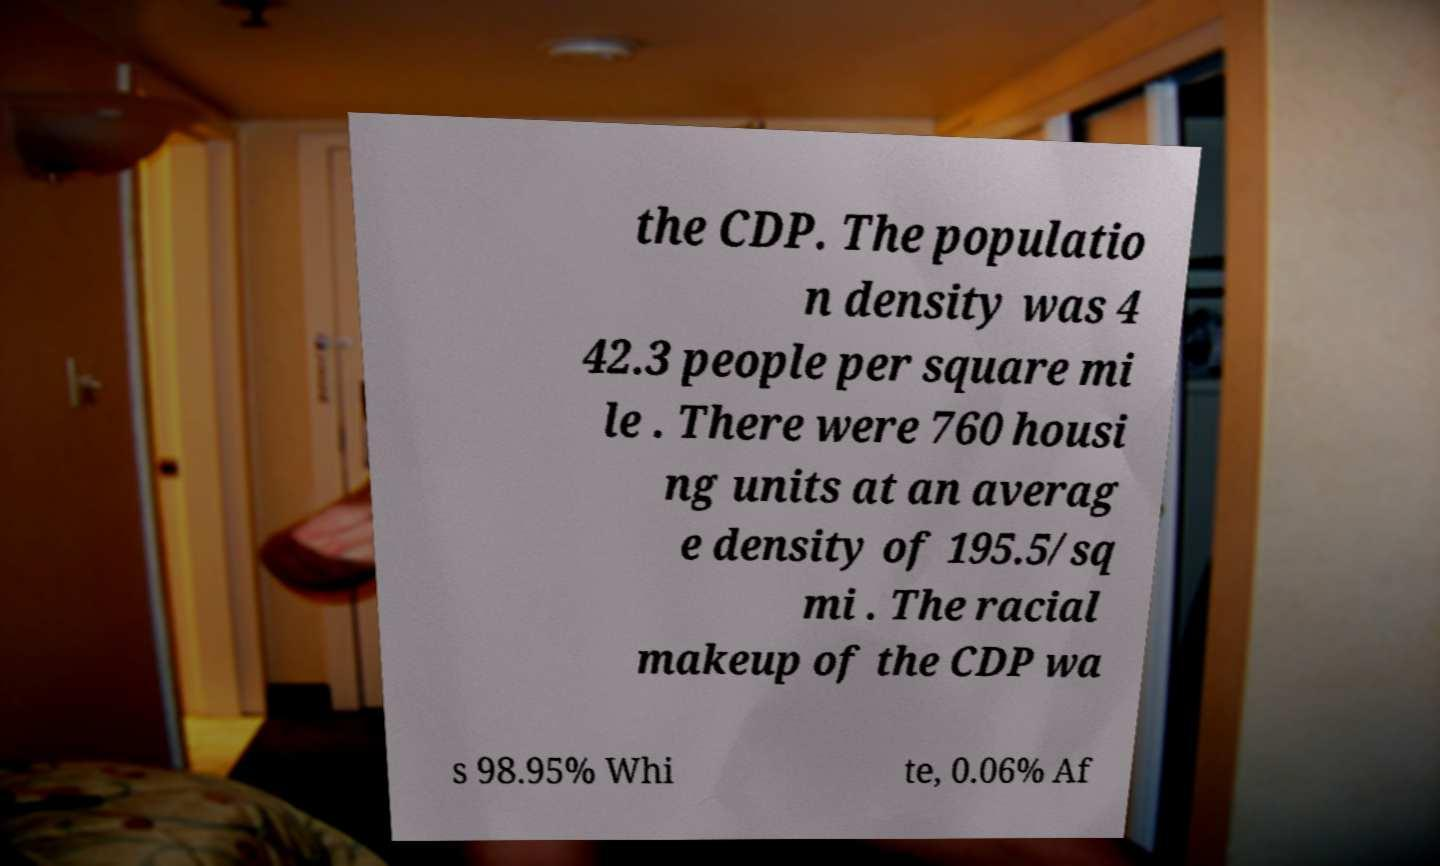Can you accurately transcribe the text from the provided image for me? the CDP. The populatio n density was 4 42.3 people per square mi le . There were 760 housi ng units at an averag e density of 195.5/sq mi . The racial makeup of the CDP wa s 98.95% Whi te, 0.06% Af 